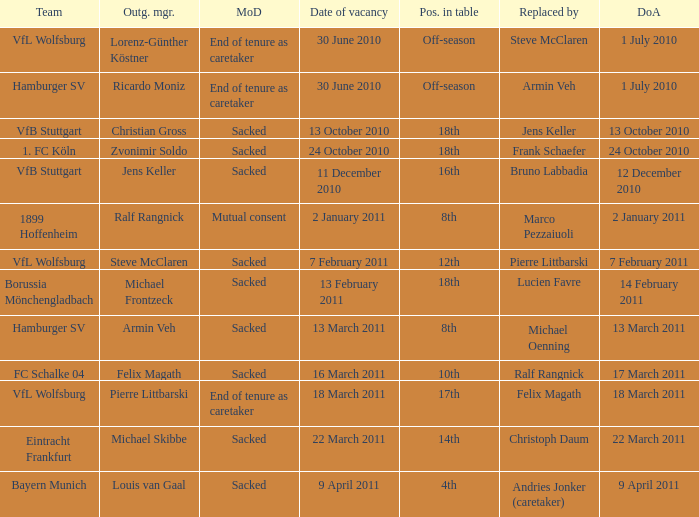When steve mcclaren is the replacer what is the manner of departure? End of tenure as caretaker. 